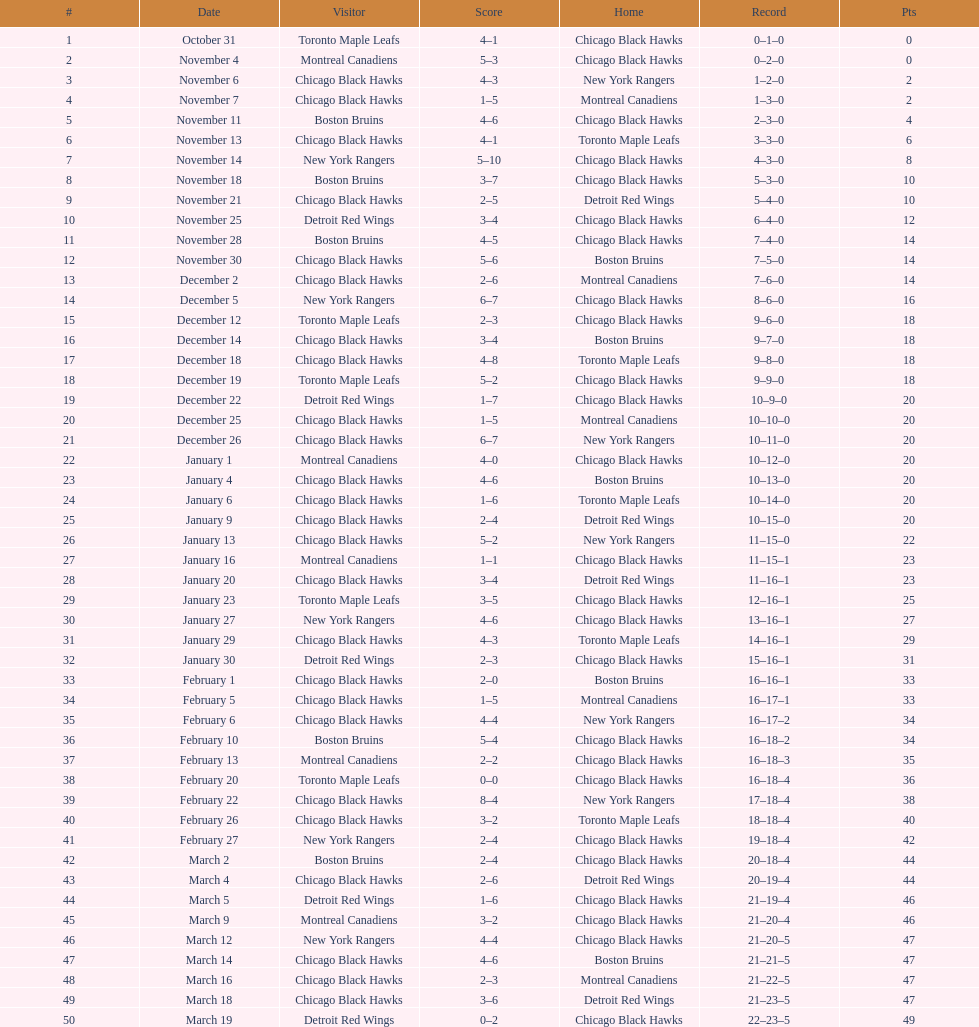What was the total amount of points scored on november 4th? 8. 